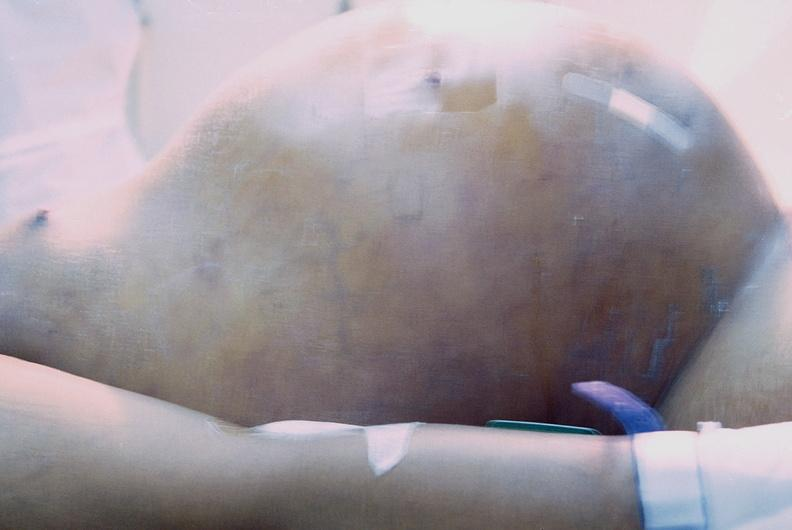where is this area in the body?
Answer the question using a single word or phrase. Abdomen 